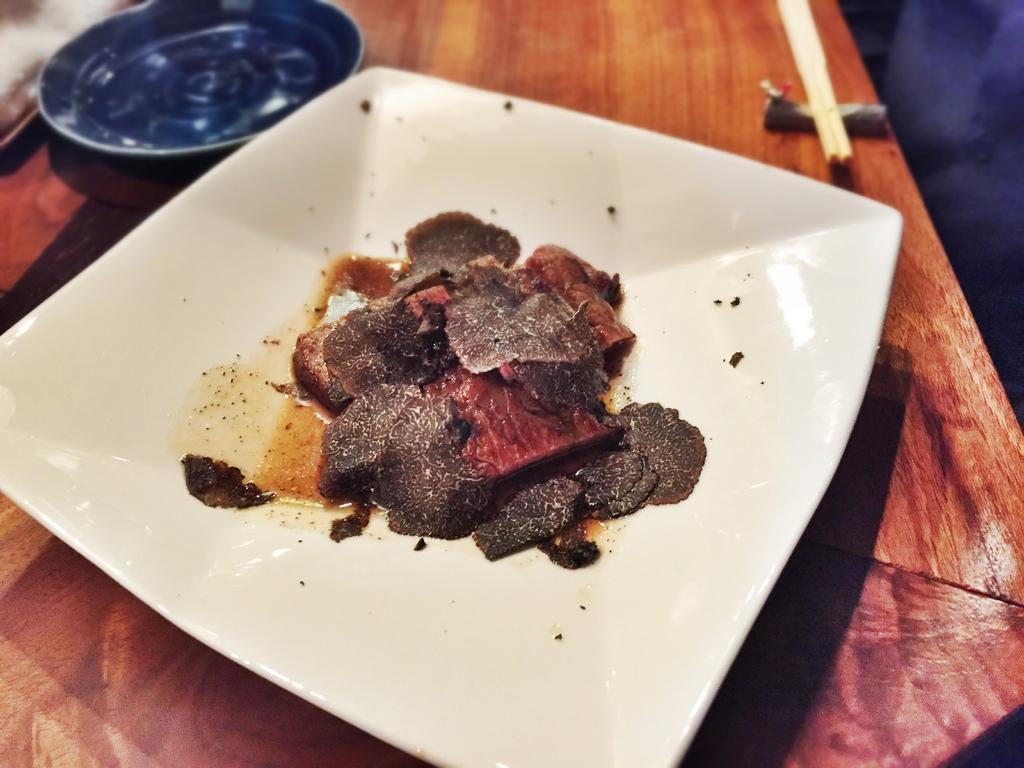How would you summarize this image in a sentence or two? In this image we can see some food items on a plate, which is placed on a surface of a table, behind it there are chopsticks and a plate. 